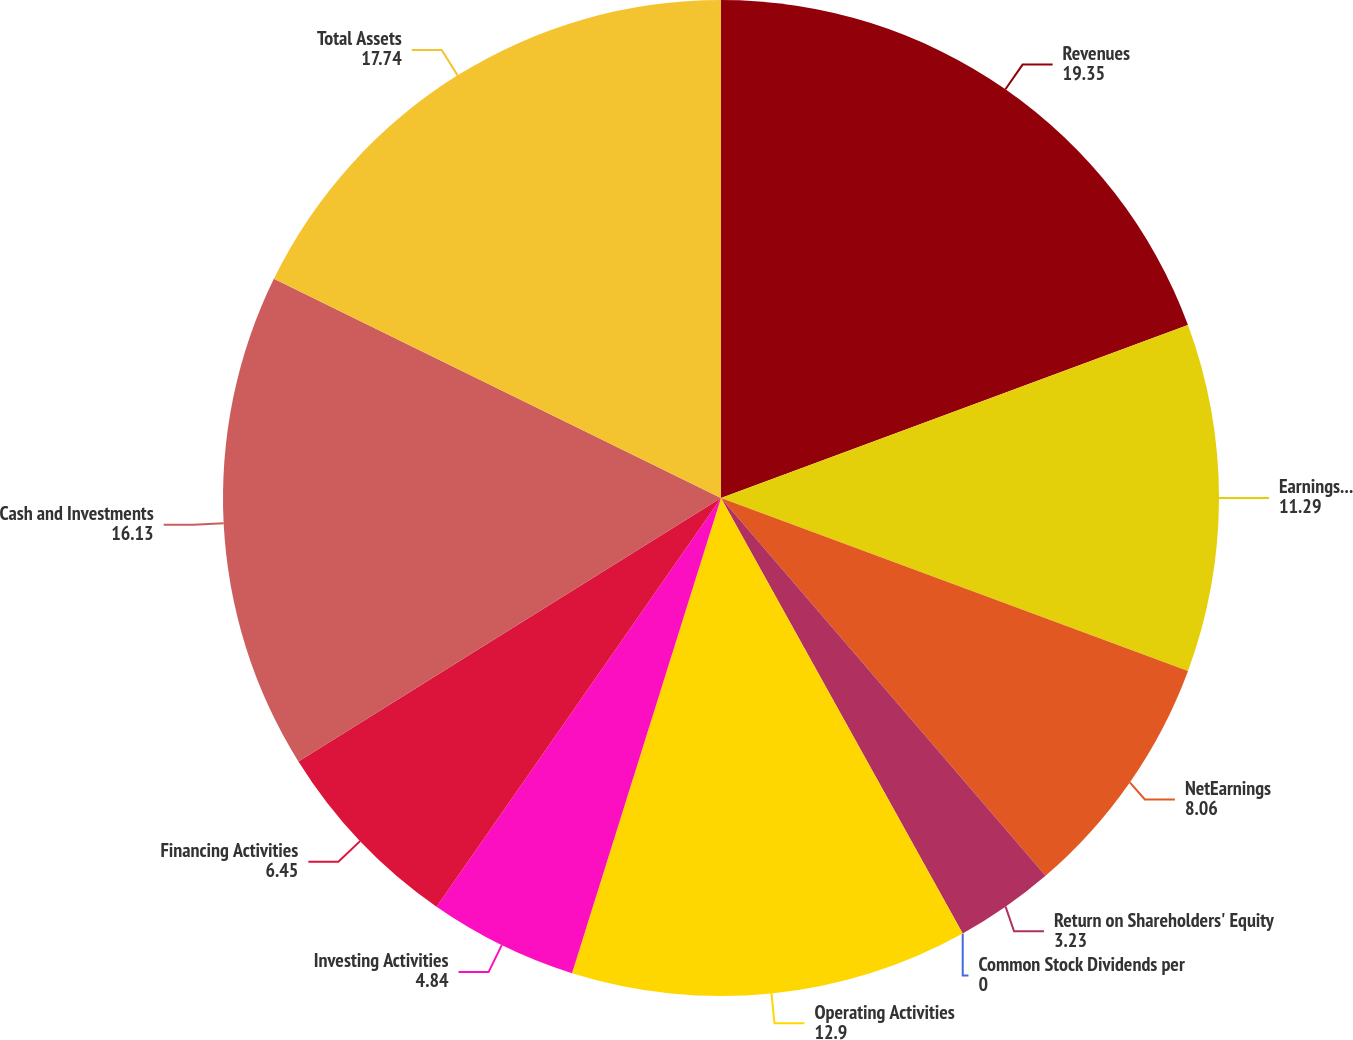<chart> <loc_0><loc_0><loc_500><loc_500><pie_chart><fcel>Revenues<fcel>Earnings From Operations<fcel>NetEarnings<fcel>Return on Shareholders' Equity<fcel>Common Stock Dividends per<fcel>Operating Activities<fcel>Investing Activities<fcel>Financing Activities<fcel>Cash and Investments<fcel>Total Assets<nl><fcel>19.35%<fcel>11.29%<fcel>8.06%<fcel>3.23%<fcel>0.0%<fcel>12.9%<fcel>4.84%<fcel>6.45%<fcel>16.13%<fcel>17.74%<nl></chart> 